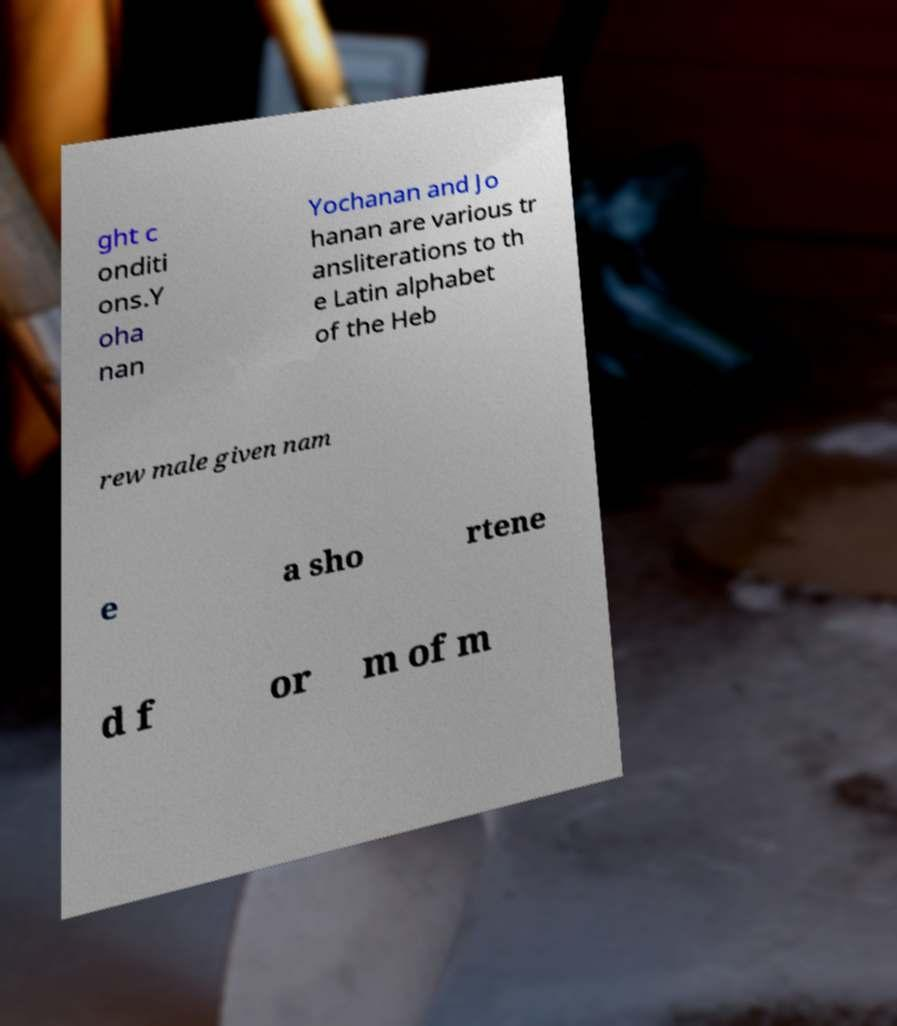I need the written content from this picture converted into text. Can you do that? ght c onditi ons.Y oha nan Yochanan and Jo hanan are various tr ansliterations to th e Latin alphabet of the Heb rew male given nam e a sho rtene d f or m of m 